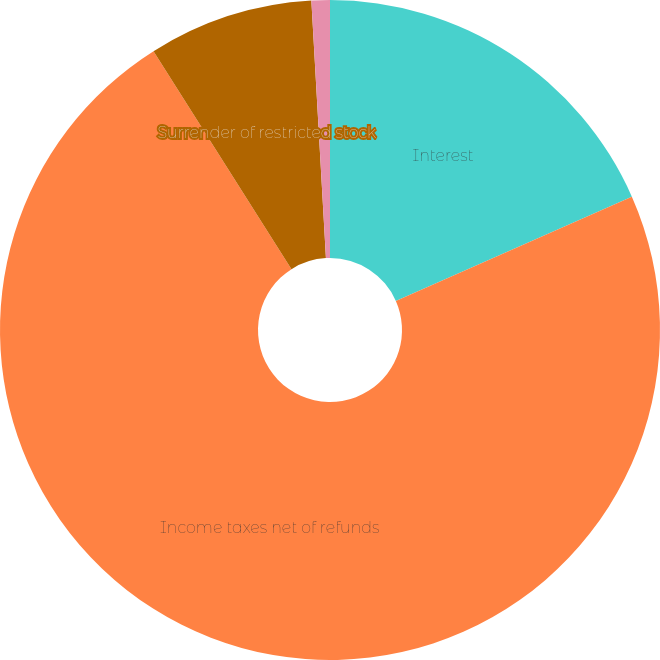Convert chart to OTSL. <chart><loc_0><loc_0><loc_500><loc_500><pie_chart><fcel>Interest<fcel>Income taxes net of refunds<fcel>Surrender of restricted stock<fcel>Conversion of zero-coupon<nl><fcel>18.38%<fcel>72.64%<fcel>8.08%<fcel>0.9%<nl></chart> 